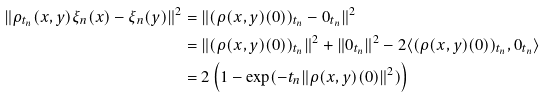Convert formula to latex. <formula><loc_0><loc_0><loc_500><loc_500>\| \rho _ { t _ { n } } ( x , y ) \xi _ { n } ( x ) - \xi _ { n } ( y ) \| ^ { 2 } & = \| ( \rho ( x , y ) ( 0 ) ) _ { t _ { n } } - 0 _ { t _ { n } } \| ^ { 2 } & \\ & = \| ( \rho ( x , y ) ( 0 ) ) _ { t _ { n } } \| ^ { 2 } + \| 0 _ { t _ { n } } \| ^ { 2 } - 2 \langle ( \rho ( x , y ) ( 0 ) ) _ { t _ { n } } , 0 _ { t _ { n } } \rangle & \\ & = 2 \left ( 1 - \exp ( - t _ { n } \| \rho ( x , y ) ( 0 ) \| ^ { 2 } ) \right ) &</formula> 